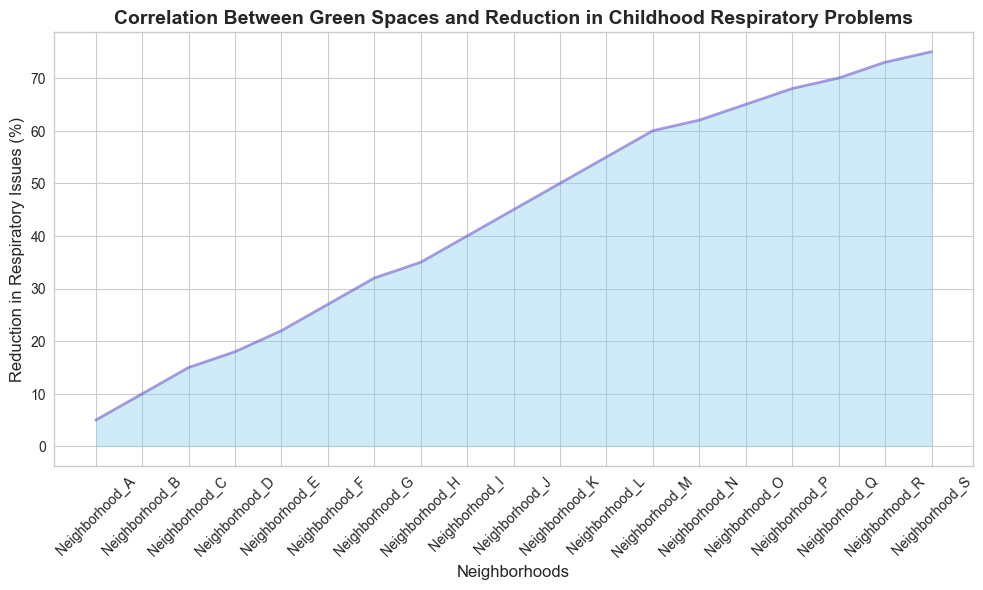what's the neighborhood with the highest reduction in respiratory issues? Identify the highest point on the chart in the y-axis related to "Reduction in Respiratory Issues." The highest point is above "Neighborhood_S" indicating a 75% reduction.
Answer: Neighborhood_S which neighborhood had exactly a 50% reduction in respiratory issues? Look for the neighborhood corresponding to the 50% mark on the y-axis. This aligns with "Neighborhood_K."
Answer: Neighborhood_K how much greater is the reduction in respiratory issues in Neighborhood_J compared to Neighborhood_A? Subtract the percentage reduction in Neighborhood_A (5%) from Neighborhood_J (45%): 45% - 5% = 40%.
Answer: 40% which neighborhoods show a reduction of respiratory issues greater than 60%? Identify points on the chart where the y-axis values exceed 60%. The neighborhoods with values greater than 60% are "Neighborhood_M" (60%), "Neighborhood_N" (62%), "Neighborhood_O" (65%), "Neighborhood_P" (68%), "Neighborhood_Q" (70%), "Neighborhood_R" (73%), and "Neighborhood_S" (75%).
Answer: Neighborhood_M, Neighborhood_N, Neighborhood_O, Neighborhood_P, Neighborhood_Q, Neighborhood_R, Neighborhood_S how does the trend of reduction in respiratory issues change as green space coverage increases? Observe the overall trend of the lines on the chart. The reduction in respiratory issues increases consistently as green space coverage rises, indicating a positive correlation between green space and respiratory health.
Answer: Increases consistently what is the difference in reduction of respiratory issues between neighborhoods with 15% and 85% green space coverage? Identify the respective reductions for 15% (Neighborhood_B, 10%) and 85% (Neighborhood_P, 68%). Calculate the difference: 68% - 10% = 58%.
Answer: 58% what is the color and shape of the area representing the reduction in respiratory issues? Describe the visual attributes of the filled area on the chart. The area is colored in sky blue and filled from the x-axis (neighborhoods) to the line representing reduction in issues.
Answer: Sky blue which neighborhood marks the first substantial increase in reduction of respiratory issues beyond 10%? Identify the first increase in reduction percentage exceeding 10% following Neighborhood_A. This occurs at Neighborhood_C with a 15% reduction.
Answer: Neighborhood_C what is the average reduction in respiratory issues for neighborhoods with 10% to 50% green space coverage? Identify neighborhoods within this range: Neighborhood_A, Neighborhood_B, Neighborhood_C, Neighborhood_D, Neighborhood_E, Neighborhood_F, Neighborhood_G, Neighborhood_H, Neighborhood_I. Sum their percentages (5% + 10% + 15% + 18% + 22% + 27% + 32% + 35% + 40% = 204%) and divide by the number of neighborhoods (9): 204% / 9 ≈ 22.67%.
Answer: 22.67% 